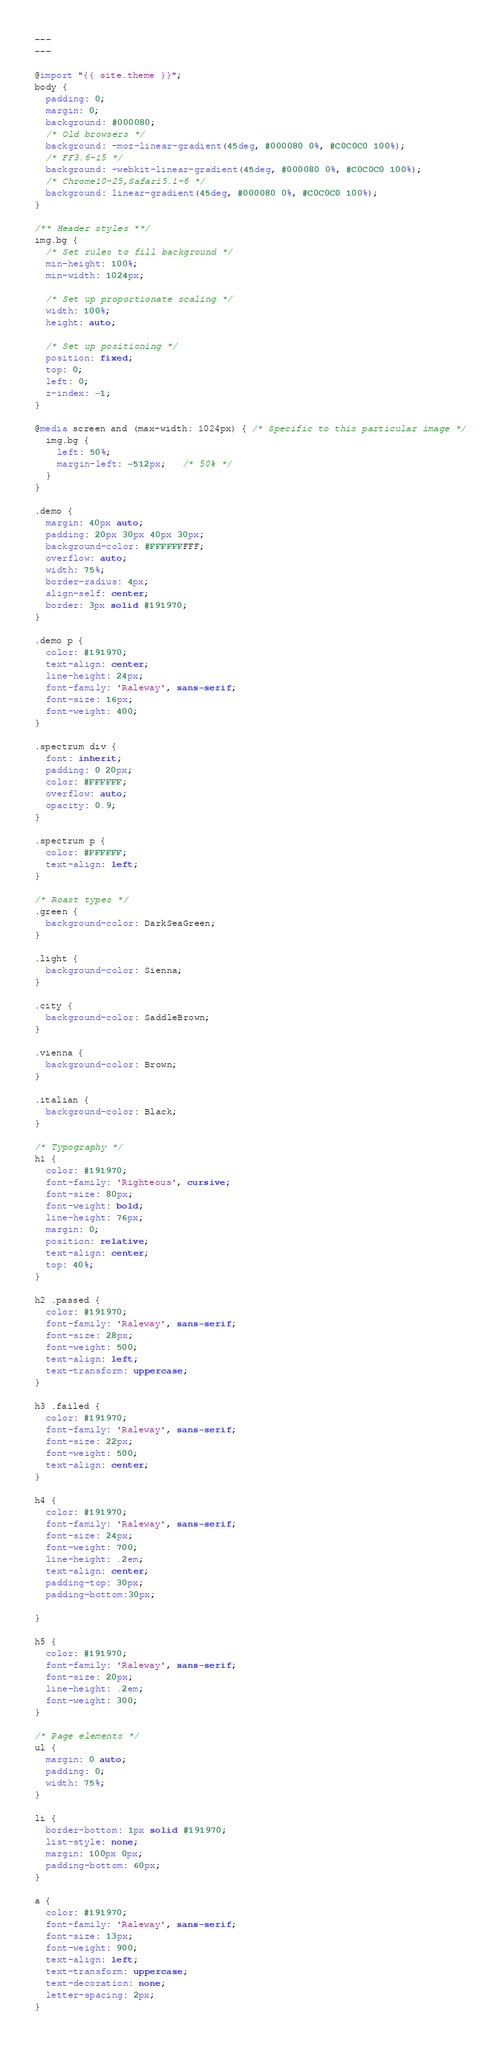Convert code to text. <code><loc_0><loc_0><loc_500><loc_500><_CSS_>---
---

@import "{{ site.theme }}";
body {
  padding: 0;
  margin: 0;
  background: #000080;
  /* Old browsers */
  background: -moz-linear-gradient(45deg, #000080 0%, #C0C0C0 100%);
  /* FF3.6-15 */
  background: -webkit-linear-gradient(45deg, #000080 0%, #C0C0C0 100%);
  /* Chrome10-25,Safari5.1-6 */
  background: linear-gradient(45deg, #000080 0%, #C0C0C0 100%);
}

/** Header styles **/
img.bg {
  /* Set rules to fill background */
  min-height: 100%;
  min-width: 1024px;
	
  /* Set up proportionate scaling */
  width: 100%;
  height: auto;
	
  /* Set up positioning */
  position: fixed;
  top: 0;
  left: 0;
  z-index: -1;
}

@media screen and (max-width: 1024px) { /* Specific to this particular image */
  img.bg {
    left: 50%;
    margin-left: -512px;   /* 50% */
  }
}

.demo {
  margin: 40px auto;
  padding: 20px 30px 40px 30px;
  background-color: #FFFFFFFFF;
  overflow: auto;
  width: 75%;
  border-radius: 4px;
  align-self: center;
  border: 3px solid #191970;
}

.demo p {
  color: #191970;
  text-align: center;
  line-height: 24px;
  font-family: 'Raleway', sans-serif;
  font-size: 16px;
  font-weight: 400;
}

.spectrum div {
  font: inherit;
  padding: 0 20px;
  color: #FFFFFF;
  overflow: auto;
  opacity: 0.9;
}

.spectrum p {
  color: #FFFFFF;
  text-align: left;
}

/* Roast types */
.green {
  background-color: DarkSeaGreen;
}

.light {
  background-color: Sienna;
}

.city {
  background-color: SaddleBrown;
}

.vienna {
  background-color: Brown;
}

.italian {
  background-color: Black;
}

/* Typography */
h1 {
  color: #191970;
  font-family: 'Righteous', cursive;
  font-size: 80px;
  font-weight: bold;
  line-height: 76px;
  margin: 0;
  position: relative;
  text-align: center;
  top: 40%;
}

h2 .passed {
  color: #191970;
  font-family: 'Raleway', sans-serif;
  font-size: 28px;
  font-weight: 500;
  text-align: left;
  text-transform: uppercase;
}

h3 .failed {
  color: #191970;
  font-family: 'Raleway', sans-serif;
  font-size: 22px;
  font-weight: 500;
  text-align: center;
}

h4 {
  color: #191970;
  font-family: 'Raleway', sans-serif;
  font-size: 24px;
  font-weight: 700;
  line-height: .2em;
  text-align: center;
  padding-top: 30px;
  padding-bottom:30px;
 
}

h5 {
  color: #191970;
  font-family: 'Raleway', sans-serif;
  font-size: 20px;
  line-height: .2em;
  font-weight: 300;
}

/* Page elements */
ul {
  margin: 0 auto;
  padding: 0;
  width: 75%;
}

li {
  border-bottom: 1px solid #191970;
  list-style: none;
  margin: 100px 0px;
  padding-bottom: 60px;
}

a {
  color: #191970;
  font-family: 'Raleway', sans-serif;
  font-size: 13px;
  font-weight: 900;
  text-align: left;
  text-transform: uppercase;
  text-decoration: none;
  letter-spacing: 2px;
}
</code> 